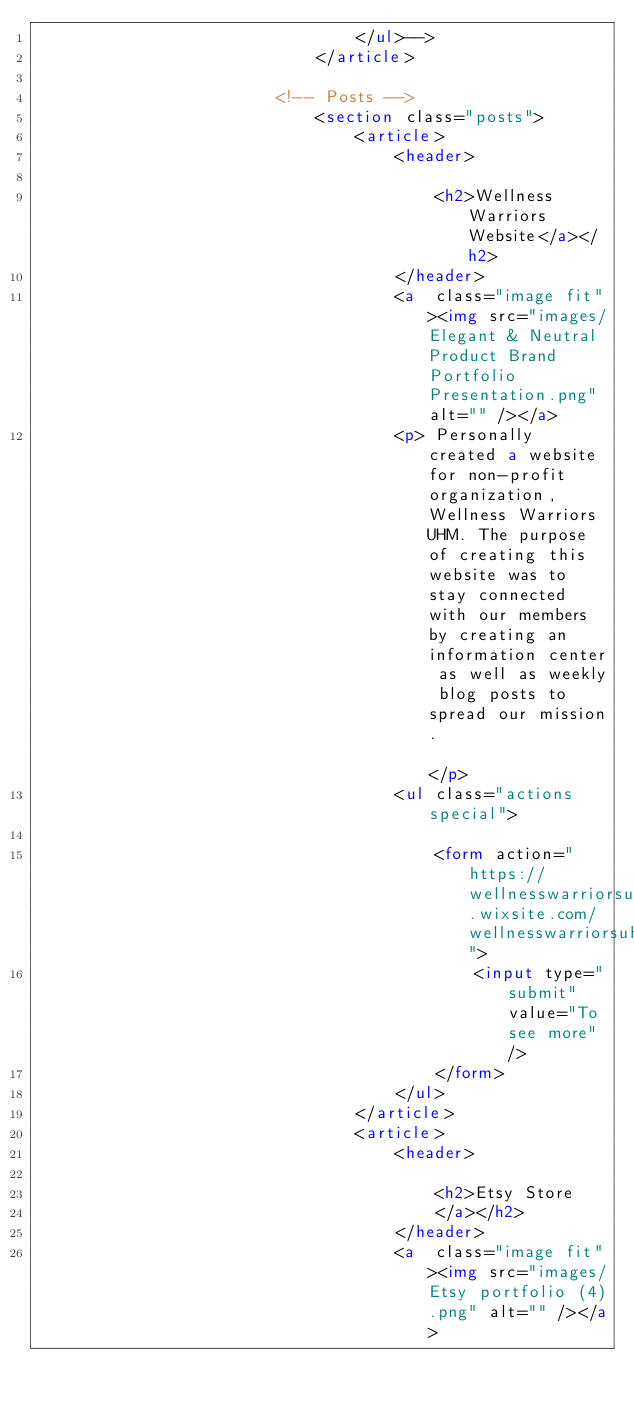<code> <loc_0><loc_0><loc_500><loc_500><_HTML_>								</ul>-->
							</article>

						<!-- Posts -->
							<section class="posts">
								<article>
									<header>
										
										<h2>Wellness Warriors Website</a></h2>
									</header>
									<a  class="image fit"><img src="images/Elegant & Neutral Product Brand Portfolio Presentation.png" alt="" /></a>
									<p> Personally created a website for non-profit organization, Wellness Warriors UHM. The purpose of creating this website was to stay connected with our members by creating an information center as well as weekly blog posts to spread our mission.                       </p>
									<ul class="actions special">
										
										<form action="https://wellnesswarriorsuh.wixsite.com/wellnesswarriorsuhm">
											<input type="submit" value="To see more" />
										</form>
									</ul>
								</article>
								<article>
									<header>
										
										<h2>Etsy Store
										</a></h2>
									</header>
									<a  class="image fit"><img src="images/Etsy portfolio (4).png" alt="" /></a></code> 